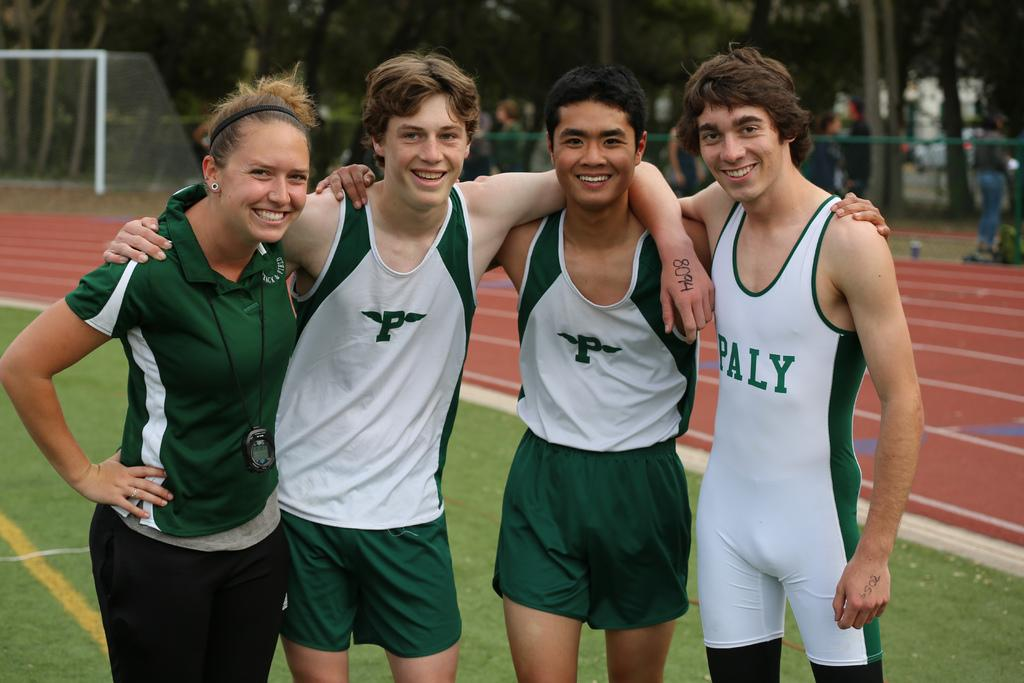<image>
Write a terse but informative summary of the picture. A woman is standing with three male athletes and one of their track suits says Paly. 